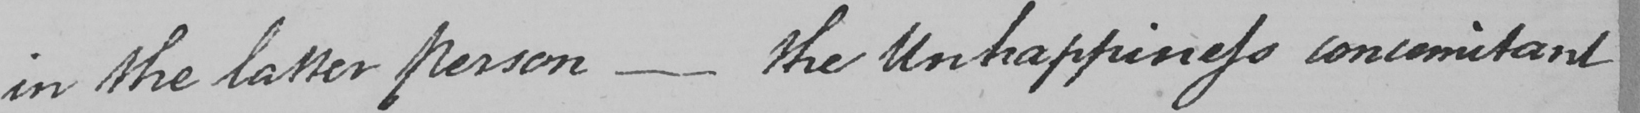Can you read and transcribe this handwriting? in the latter person  _  the Unhappiness concomitant 